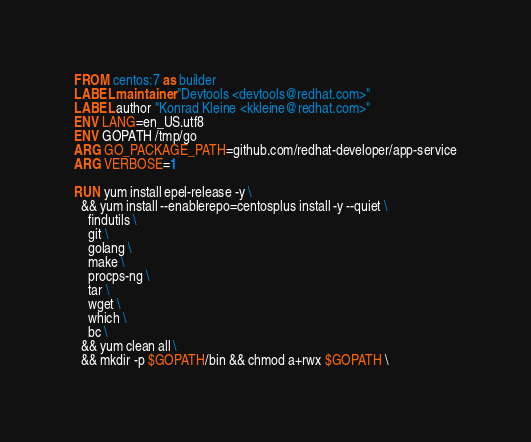<code> <loc_0><loc_0><loc_500><loc_500><_Dockerfile_>FROM centos:7 as builder
LABEL maintainer "Devtools <devtools@redhat.com>"
LABEL author "Konrad Kleine <kkleine@redhat.com>"
ENV LANG=en_US.utf8
ENV GOPATH /tmp/go
ARG GO_PACKAGE_PATH=github.com/redhat-developer/app-service
ARG VERBOSE=1

RUN yum install epel-release -y \
  && yum install --enablerepo=centosplus install -y --quiet \
    findutils \
    git \
    golang \
    make \
    procps-ng \
    tar \
    wget \
    which \
    bc \
  && yum clean all \
  && mkdir -p $GOPATH/bin && chmod a+rwx $GOPATH \</code> 